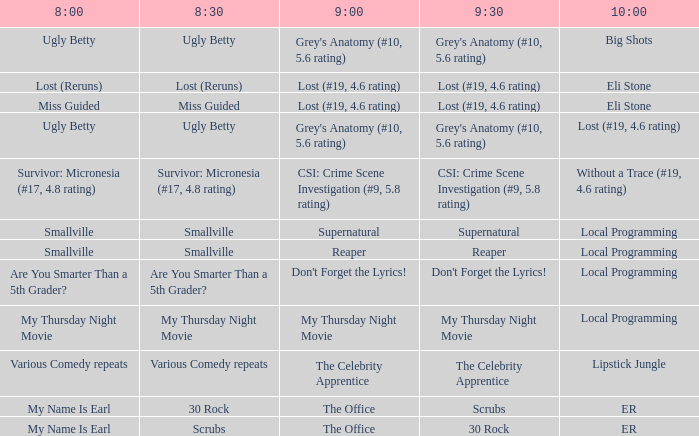What takes place at 9:30 when at 8:30 it is cleanse? 30 Rock. 